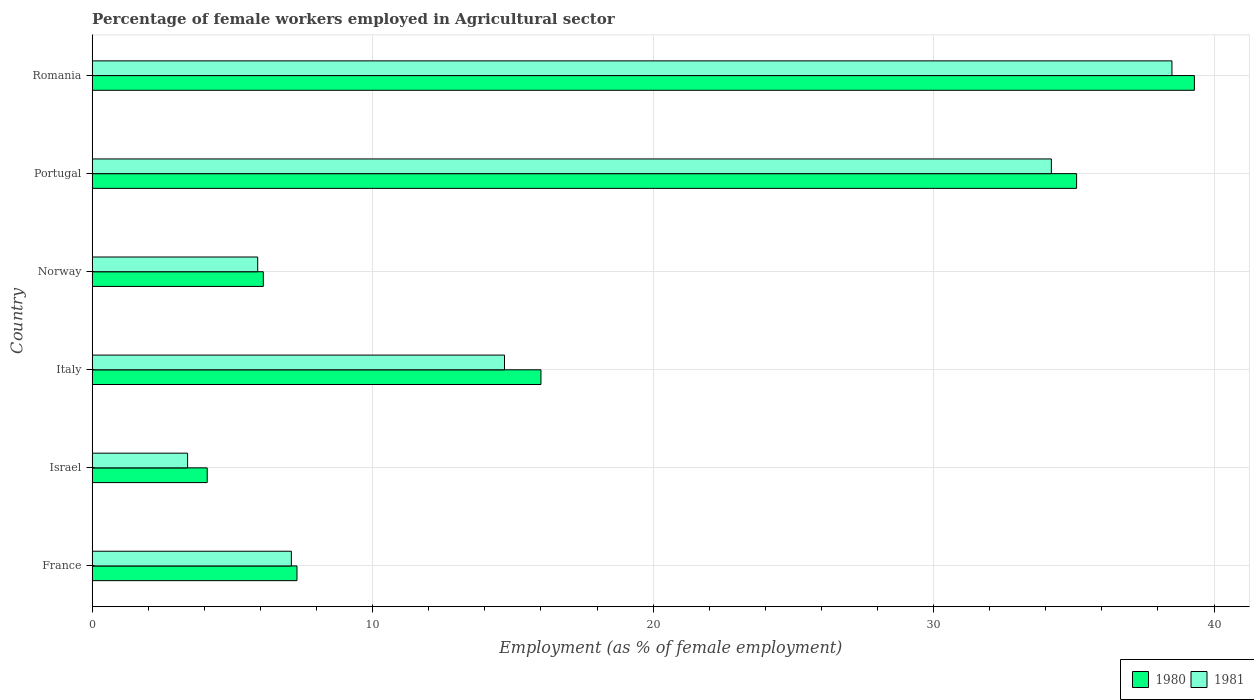How many groups of bars are there?
Keep it short and to the point. 6. How many bars are there on the 2nd tick from the bottom?
Provide a short and direct response. 2. What is the percentage of females employed in Agricultural sector in 1981 in Israel?
Provide a succinct answer. 3.4. Across all countries, what is the maximum percentage of females employed in Agricultural sector in 1981?
Ensure brevity in your answer.  38.5. Across all countries, what is the minimum percentage of females employed in Agricultural sector in 1981?
Provide a succinct answer. 3.4. In which country was the percentage of females employed in Agricultural sector in 1980 maximum?
Offer a very short reply. Romania. In which country was the percentage of females employed in Agricultural sector in 1981 minimum?
Provide a short and direct response. Israel. What is the total percentage of females employed in Agricultural sector in 1981 in the graph?
Keep it short and to the point. 103.8. What is the difference between the percentage of females employed in Agricultural sector in 1981 in Italy and that in Norway?
Provide a short and direct response. 8.8. What is the difference between the percentage of females employed in Agricultural sector in 1981 in Italy and the percentage of females employed in Agricultural sector in 1980 in Norway?
Offer a terse response. 8.6. What is the average percentage of females employed in Agricultural sector in 1981 per country?
Ensure brevity in your answer.  17.3. What is the difference between the percentage of females employed in Agricultural sector in 1981 and percentage of females employed in Agricultural sector in 1980 in Norway?
Your answer should be very brief. -0.2. In how many countries, is the percentage of females employed in Agricultural sector in 1981 greater than 32 %?
Offer a very short reply. 2. What is the ratio of the percentage of females employed in Agricultural sector in 1980 in Norway to that in Portugal?
Give a very brief answer. 0.17. What is the difference between the highest and the second highest percentage of females employed in Agricultural sector in 1981?
Your answer should be very brief. 4.3. What is the difference between the highest and the lowest percentage of females employed in Agricultural sector in 1980?
Give a very brief answer. 35.2. Is the sum of the percentage of females employed in Agricultural sector in 1981 in France and Portugal greater than the maximum percentage of females employed in Agricultural sector in 1980 across all countries?
Ensure brevity in your answer.  Yes. What does the 2nd bar from the bottom in France represents?
Your response must be concise. 1981. Are all the bars in the graph horizontal?
Your answer should be very brief. Yes. What is the difference between two consecutive major ticks on the X-axis?
Your response must be concise. 10. Are the values on the major ticks of X-axis written in scientific E-notation?
Your response must be concise. No. Does the graph contain any zero values?
Offer a terse response. No. Does the graph contain grids?
Provide a succinct answer. Yes. How many legend labels are there?
Your answer should be very brief. 2. What is the title of the graph?
Ensure brevity in your answer.  Percentage of female workers employed in Agricultural sector. What is the label or title of the X-axis?
Provide a succinct answer. Employment (as % of female employment). What is the Employment (as % of female employment) in 1980 in France?
Give a very brief answer. 7.3. What is the Employment (as % of female employment) in 1981 in France?
Offer a very short reply. 7.1. What is the Employment (as % of female employment) of 1980 in Israel?
Your answer should be compact. 4.1. What is the Employment (as % of female employment) in 1981 in Israel?
Offer a terse response. 3.4. What is the Employment (as % of female employment) of 1981 in Italy?
Offer a very short reply. 14.7. What is the Employment (as % of female employment) of 1980 in Norway?
Ensure brevity in your answer.  6.1. What is the Employment (as % of female employment) in 1981 in Norway?
Provide a succinct answer. 5.9. What is the Employment (as % of female employment) in 1980 in Portugal?
Offer a terse response. 35.1. What is the Employment (as % of female employment) of 1981 in Portugal?
Keep it short and to the point. 34.2. What is the Employment (as % of female employment) in 1980 in Romania?
Offer a terse response. 39.3. What is the Employment (as % of female employment) of 1981 in Romania?
Make the answer very short. 38.5. Across all countries, what is the maximum Employment (as % of female employment) in 1980?
Keep it short and to the point. 39.3. Across all countries, what is the maximum Employment (as % of female employment) in 1981?
Give a very brief answer. 38.5. Across all countries, what is the minimum Employment (as % of female employment) in 1980?
Your answer should be compact. 4.1. Across all countries, what is the minimum Employment (as % of female employment) in 1981?
Give a very brief answer. 3.4. What is the total Employment (as % of female employment) of 1980 in the graph?
Offer a very short reply. 107.9. What is the total Employment (as % of female employment) in 1981 in the graph?
Offer a terse response. 103.8. What is the difference between the Employment (as % of female employment) of 1980 in France and that in Israel?
Offer a terse response. 3.2. What is the difference between the Employment (as % of female employment) of 1981 in France and that in Israel?
Provide a short and direct response. 3.7. What is the difference between the Employment (as % of female employment) of 1980 in France and that in Italy?
Give a very brief answer. -8.7. What is the difference between the Employment (as % of female employment) in 1980 in France and that in Portugal?
Provide a succinct answer. -27.8. What is the difference between the Employment (as % of female employment) of 1981 in France and that in Portugal?
Offer a very short reply. -27.1. What is the difference between the Employment (as % of female employment) in 1980 in France and that in Romania?
Keep it short and to the point. -32. What is the difference between the Employment (as % of female employment) in 1981 in France and that in Romania?
Give a very brief answer. -31.4. What is the difference between the Employment (as % of female employment) in 1980 in Israel and that in Italy?
Provide a short and direct response. -11.9. What is the difference between the Employment (as % of female employment) of 1981 in Israel and that in Italy?
Make the answer very short. -11.3. What is the difference between the Employment (as % of female employment) in 1980 in Israel and that in Portugal?
Offer a terse response. -31. What is the difference between the Employment (as % of female employment) in 1981 in Israel and that in Portugal?
Your answer should be compact. -30.8. What is the difference between the Employment (as % of female employment) in 1980 in Israel and that in Romania?
Provide a short and direct response. -35.2. What is the difference between the Employment (as % of female employment) of 1981 in Israel and that in Romania?
Your answer should be very brief. -35.1. What is the difference between the Employment (as % of female employment) of 1980 in Italy and that in Norway?
Provide a short and direct response. 9.9. What is the difference between the Employment (as % of female employment) of 1981 in Italy and that in Norway?
Offer a very short reply. 8.8. What is the difference between the Employment (as % of female employment) in 1980 in Italy and that in Portugal?
Offer a very short reply. -19.1. What is the difference between the Employment (as % of female employment) in 1981 in Italy and that in Portugal?
Make the answer very short. -19.5. What is the difference between the Employment (as % of female employment) in 1980 in Italy and that in Romania?
Give a very brief answer. -23.3. What is the difference between the Employment (as % of female employment) of 1981 in Italy and that in Romania?
Your answer should be compact. -23.8. What is the difference between the Employment (as % of female employment) of 1980 in Norway and that in Portugal?
Your answer should be very brief. -29. What is the difference between the Employment (as % of female employment) of 1981 in Norway and that in Portugal?
Your answer should be compact. -28.3. What is the difference between the Employment (as % of female employment) in 1980 in Norway and that in Romania?
Keep it short and to the point. -33.2. What is the difference between the Employment (as % of female employment) of 1981 in Norway and that in Romania?
Provide a succinct answer. -32.6. What is the difference between the Employment (as % of female employment) in 1980 in Portugal and that in Romania?
Keep it short and to the point. -4.2. What is the difference between the Employment (as % of female employment) of 1981 in Portugal and that in Romania?
Offer a terse response. -4.3. What is the difference between the Employment (as % of female employment) of 1980 in France and the Employment (as % of female employment) of 1981 in Norway?
Your response must be concise. 1.4. What is the difference between the Employment (as % of female employment) in 1980 in France and the Employment (as % of female employment) in 1981 in Portugal?
Give a very brief answer. -26.9. What is the difference between the Employment (as % of female employment) of 1980 in France and the Employment (as % of female employment) of 1981 in Romania?
Keep it short and to the point. -31.2. What is the difference between the Employment (as % of female employment) in 1980 in Israel and the Employment (as % of female employment) in 1981 in Portugal?
Provide a succinct answer. -30.1. What is the difference between the Employment (as % of female employment) of 1980 in Israel and the Employment (as % of female employment) of 1981 in Romania?
Ensure brevity in your answer.  -34.4. What is the difference between the Employment (as % of female employment) in 1980 in Italy and the Employment (as % of female employment) in 1981 in Norway?
Make the answer very short. 10.1. What is the difference between the Employment (as % of female employment) of 1980 in Italy and the Employment (as % of female employment) of 1981 in Portugal?
Keep it short and to the point. -18.2. What is the difference between the Employment (as % of female employment) in 1980 in Italy and the Employment (as % of female employment) in 1981 in Romania?
Give a very brief answer. -22.5. What is the difference between the Employment (as % of female employment) of 1980 in Norway and the Employment (as % of female employment) of 1981 in Portugal?
Make the answer very short. -28.1. What is the difference between the Employment (as % of female employment) in 1980 in Norway and the Employment (as % of female employment) in 1981 in Romania?
Offer a terse response. -32.4. What is the average Employment (as % of female employment) in 1980 per country?
Offer a terse response. 17.98. What is the average Employment (as % of female employment) of 1981 per country?
Your answer should be compact. 17.3. What is the difference between the Employment (as % of female employment) of 1980 and Employment (as % of female employment) of 1981 in Portugal?
Offer a very short reply. 0.9. What is the ratio of the Employment (as % of female employment) of 1980 in France to that in Israel?
Your answer should be very brief. 1.78. What is the ratio of the Employment (as % of female employment) of 1981 in France to that in Israel?
Offer a very short reply. 2.09. What is the ratio of the Employment (as % of female employment) of 1980 in France to that in Italy?
Provide a short and direct response. 0.46. What is the ratio of the Employment (as % of female employment) in 1981 in France to that in Italy?
Keep it short and to the point. 0.48. What is the ratio of the Employment (as % of female employment) in 1980 in France to that in Norway?
Make the answer very short. 1.2. What is the ratio of the Employment (as % of female employment) in 1981 in France to that in Norway?
Your answer should be compact. 1.2. What is the ratio of the Employment (as % of female employment) in 1980 in France to that in Portugal?
Keep it short and to the point. 0.21. What is the ratio of the Employment (as % of female employment) of 1981 in France to that in Portugal?
Keep it short and to the point. 0.21. What is the ratio of the Employment (as % of female employment) of 1980 in France to that in Romania?
Give a very brief answer. 0.19. What is the ratio of the Employment (as % of female employment) of 1981 in France to that in Romania?
Provide a succinct answer. 0.18. What is the ratio of the Employment (as % of female employment) of 1980 in Israel to that in Italy?
Give a very brief answer. 0.26. What is the ratio of the Employment (as % of female employment) of 1981 in Israel to that in Italy?
Provide a succinct answer. 0.23. What is the ratio of the Employment (as % of female employment) of 1980 in Israel to that in Norway?
Your response must be concise. 0.67. What is the ratio of the Employment (as % of female employment) in 1981 in Israel to that in Norway?
Keep it short and to the point. 0.58. What is the ratio of the Employment (as % of female employment) of 1980 in Israel to that in Portugal?
Provide a succinct answer. 0.12. What is the ratio of the Employment (as % of female employment) in 1981 in Israel to that in Portugal?
Ensure brevity in your answer.  0.1. What is the ratio of the Employment (as % of female employment) in 1980 in Israel to that in Romania?
Provide a short and direct response. 0.1. What is the ratio of the Employment (as % of female employment) of 1981 in Israel to that in Romania?
Provide a succinct answer. 0.09. What is the ratio of the Employment (as % of female employment) in 1980 in Italy to that in Norway?
Your answer should be compact. 2.62. What is the ratio of the Employment (as % of female employment) in 1981 in Italy to that in Norway?
Your answer should be very brief. 2.49. What is the ratio of the Employment (as % of female employment) of 1980 in Italy to that in Portugal?
Provide a succinct answer. 0.46. What is the ratio of the Employment (as % of female employment) in 1981 in Italy to that in Portugal?
Your answer should be very brief. 0.43. What is the ratio of the Employment (as % of female employment) in 1980 in Italy to that in Romania?
Offer a very short reply. 0.41. What is the ratio of the Employment (as % of female employment) of 1981 in Italy to that in Romania?
Make the answer very short. 0.38. What is the ratio of the Employment (as % of female employment) in 1980 in Norway to that in Portugal?
Make the answer very short. 0.17. What is the ratio of the Employment (as % of female employment) of 1981 in Norway to that in Portugal?
Give a very brief answer. 0.17. What is the ratio of the Employment (as % of female employment) of 1980 in Norway to that in Romania?
Offer a very short reply. 0.16. What is the ratio of the Employment (as % of female employment) of 1981 in Norway to that in Romania?
Provide a short and direct response. 0.15. What is the ratio of the Employment (as % of female employment) in 1980 in Portugal to that in Romania?
Your answer should be very brief. 0.89. What is the ratio of the Employment (as % of female employment) of 1981 in Portugal to that in Romania?
Your answer should be compact. 0.89. What is the difference between the highest and the second highest Employment (as % of female employment) in 1981?
Keep it short and to the point. 4.3. What is the difference between the highest and the lowest Employment (as % of female employment) in 1980?
Provide a short and direct response. 35.2. What is the difference between the highest and the lowest Employment (as % of female employment) in 1981?
Provide a short and direct response. 35.1. 